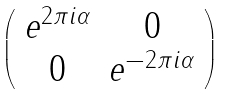<formula> <loc_0><loc_0><loc_500><loc_500>\left ( \begin{array} { c c } e ^ { 2 \pi i \alpha } & 0 \\ 0 & e ^ { - 2 \pi i \alpha } \end{array} \right )</formula> 